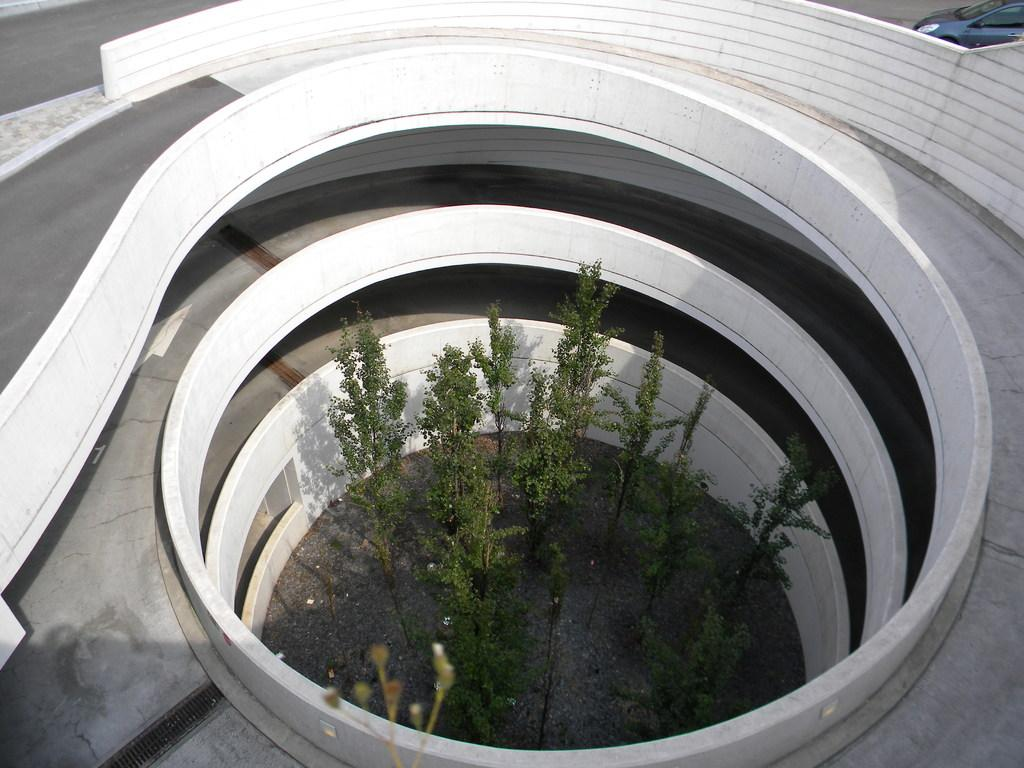What type of living organisms can be seen in the image? Plants can be seen in the image. What architectural feature is present in the image? There appears to be a ramp in the image. Where is the vehicle located in the image? The vehicle is at the top right of the image. What type of account is being discussed in the image? There is no account being discussed in the image; it features plants, a ramp, and a vehicle. How many windows are visible in the image? There are no windows visible in the image. 